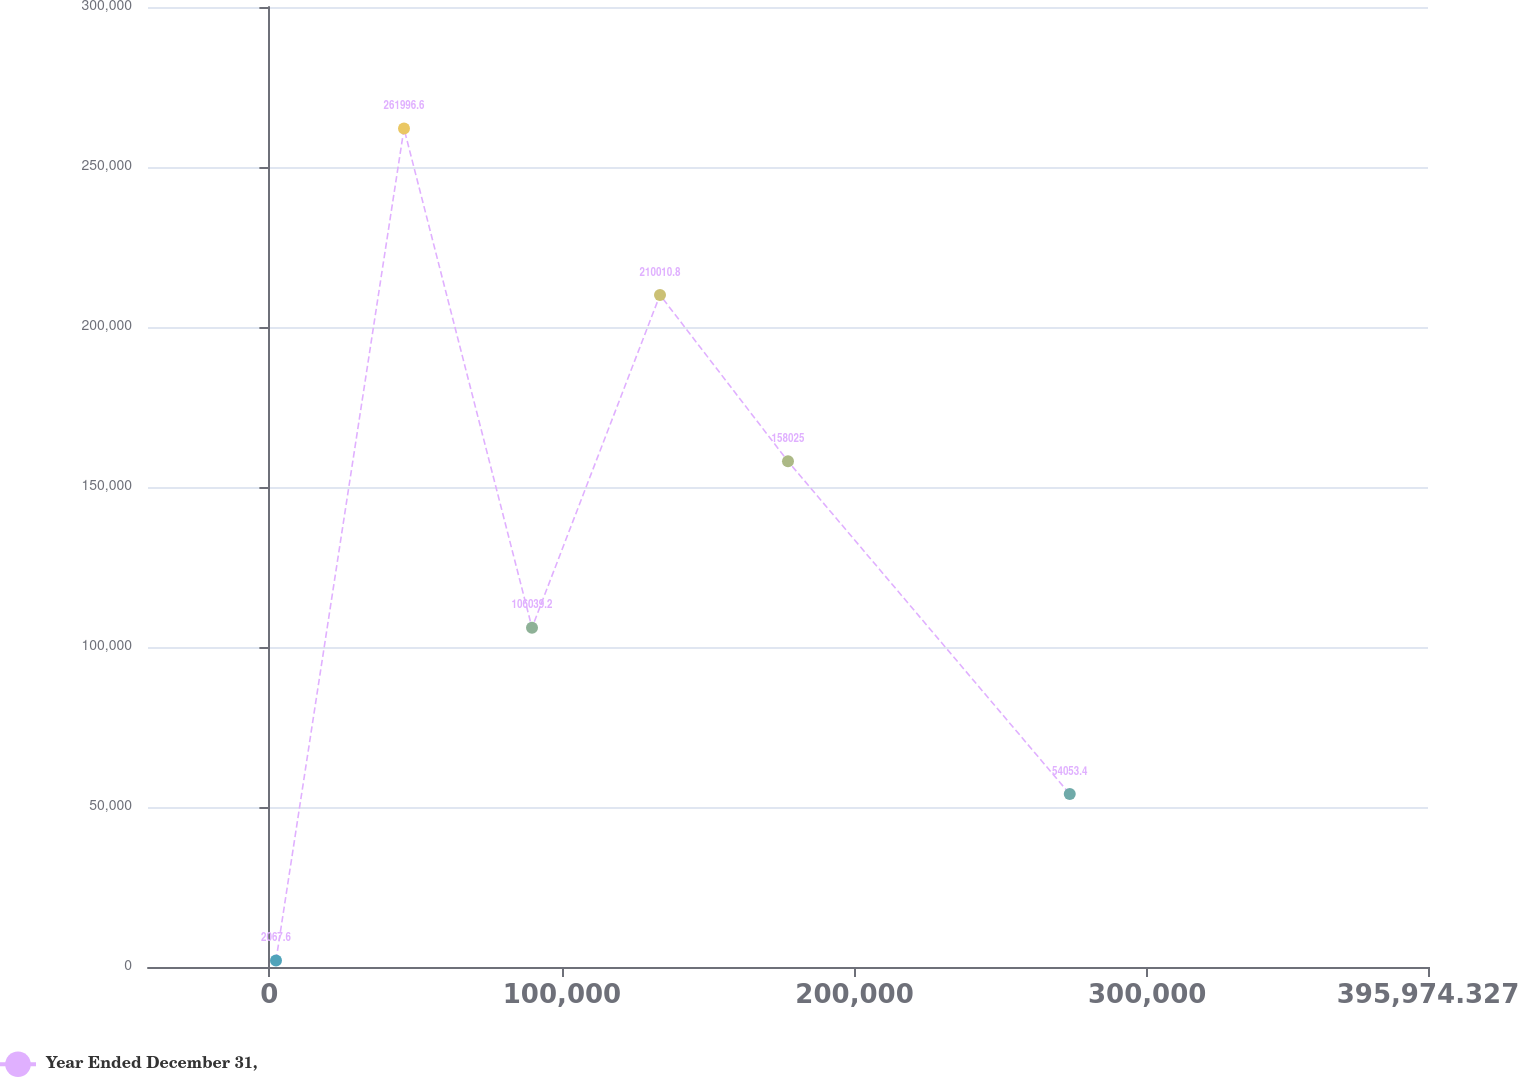Convert chart to OTSL. <chart><loc_0><loc_0><loc_500><loc_500><line_chart><ecel><fcel>Year Ended December 31,<nl><fcel>2261.56<fcel>2067.6<nl><fcel>46007.4<fcel>261997<nl><fcel>89753.3<fcel>106039<nl><fcel>133499<fcel>210011<nl><fcel>177245<fcel>158025<nl><fcel>273534<fcel>54053.4<nl><fcel>439720<fcel>521926<nl></chart> 